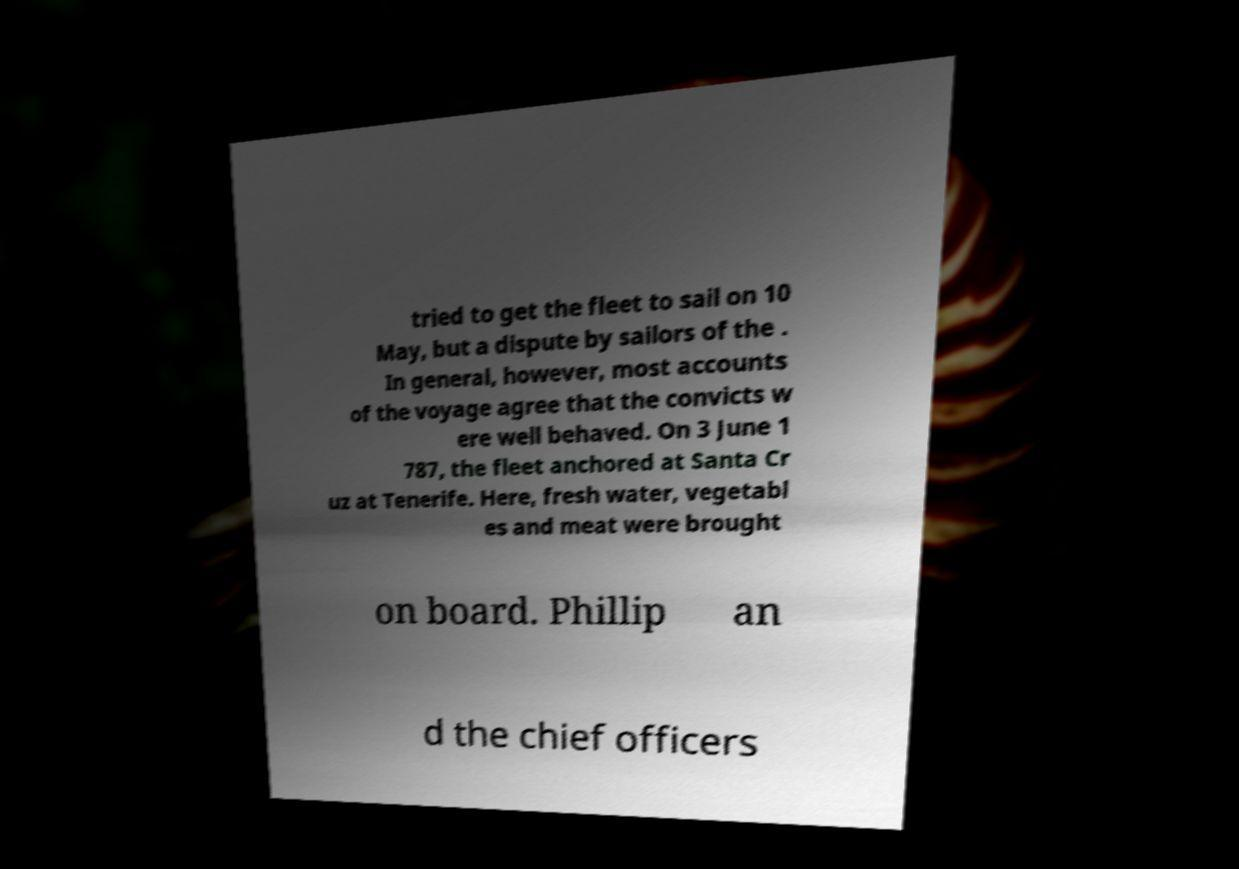Please read and relay the text visible in this image. What does it say? tried to get the fleet to sail on 10 May, but a dispute by sailors of the . In general, however, most accounts of the voyage agree that the convicts w ere well behaved. On 3 June 1 787, the fleet anchored at Santa Cr uz at Tenerife. Here, fresh water, vegetabl es and meat were brought on board. Phillip an d the chief officers 